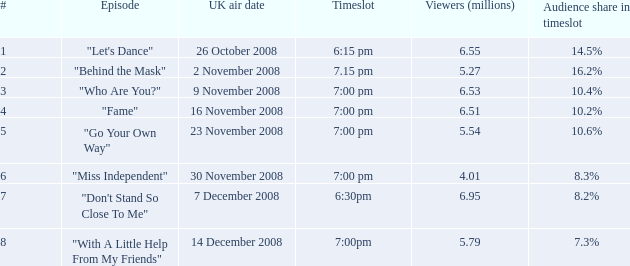2%? 1.0. 